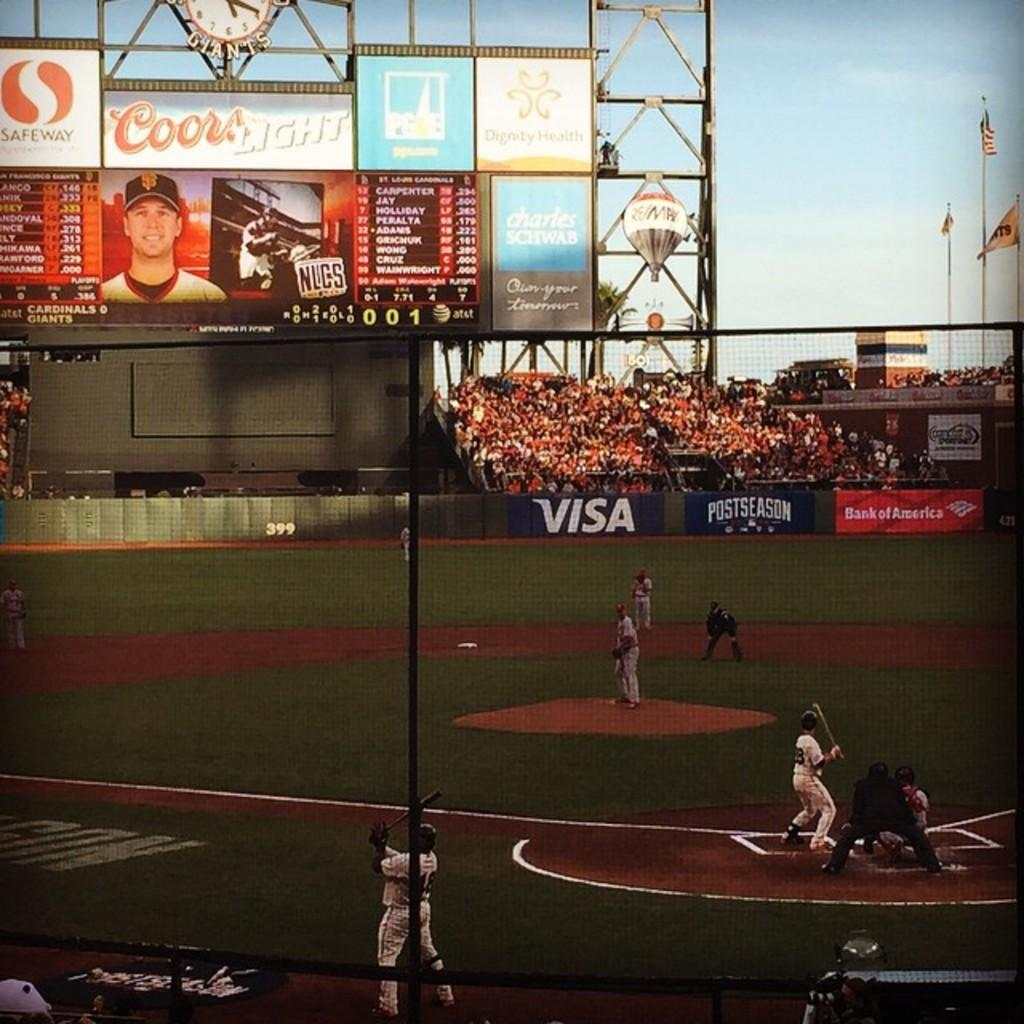<image>
Render a clear and concise summary of the photo. Visa is being advertised at this team's ground. 